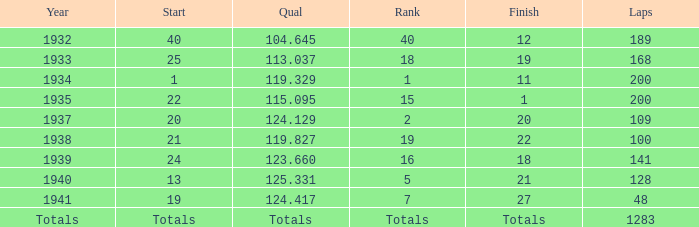What year did he start at 13? 1940.0. 